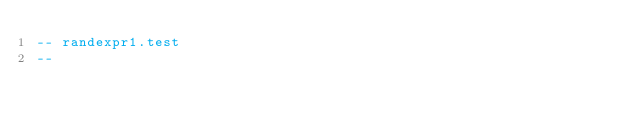<code> <loc_0><loc_0><loc_500><loc_500><_SQL_>-- randexpr1.test
-- </code> 